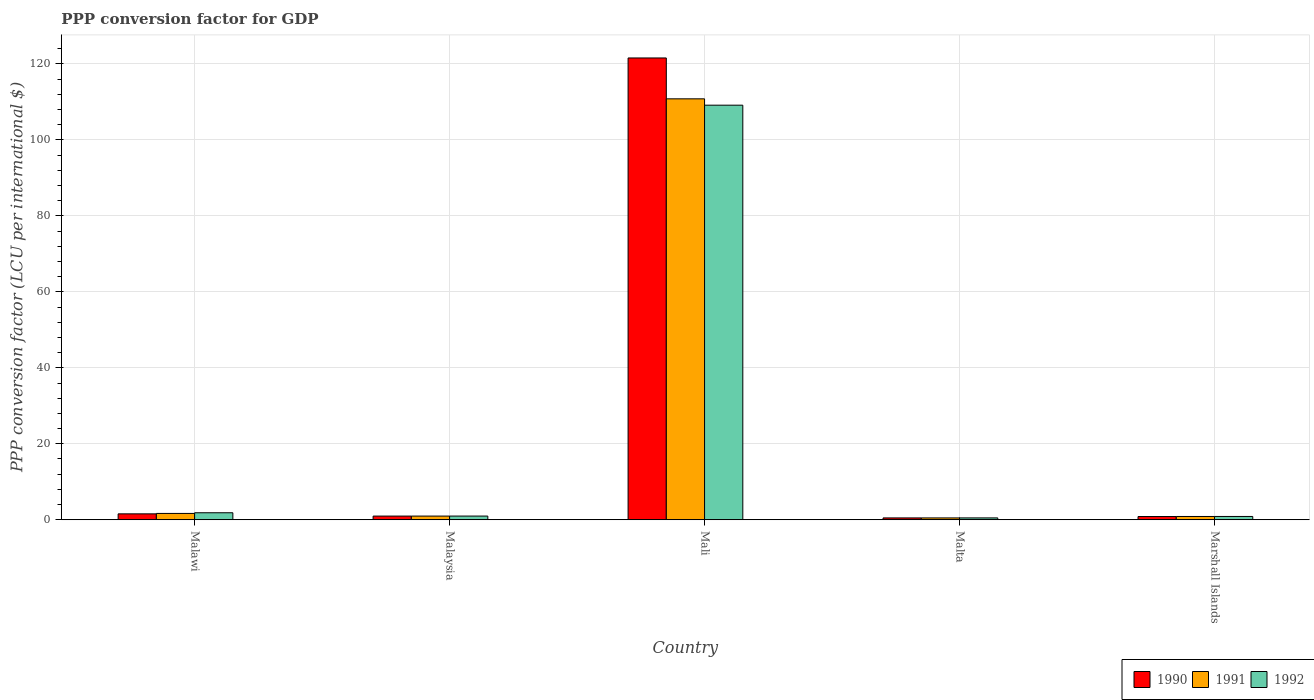How many different coloured bars are there?
Your answer should be compact. 3. How many groups of bars are there?
Your answer should be compact. 5. Are the number of bars on each tick of the X-axis equal?
Provide a succinct answer. Yes. How many bars are there on the 1st tick from the left?
Make the answer very short. 3. What is the label of the 3rd group of bars from the left?
Keep it short and to the point. Mali. In how many cases, is the number of bars for a given country not equal to the number of legend labels?
Make the answer very short. 0. What is the PPP conversion factor for GDP in 1990 in Malta?
Your answer should be very brief. 0.49. Across all countries, what is the maximum PPP conversion factor for GDP in 1991?
Provide a succinct answer. 110.8. Across all countries, what is the minimum PPP conversion factor for GDP in 1992?
Offer a very short reply. 0.49. In which country was the PPP conversion factor for GDP in 1990 maximum?
Your answer should be very brief. Mali. In which country was the PPP conversion factor for GDP in 1991 minimum?
Offer a very short reply. Malta. What is the total PPP conversion factor for GDP in 1992 in the graph?
Your answer should be very brief. 113.32. What is the difference between the PPP conversion factor for GDP in 1990 in Malawi and that in Malta?
Provide a succinct answer. 1.07. What is the difference between the PPP conversion factor for GDP in 1990 in Malta and the PPP conversion factor for GDP in 1991 in Marshall Islands?
Ensure brevity in your answer.  -0.38. What is the average PPP conversion factor for GDP in 1990 per country?
Your answer should be compact. 25.08. What is the difference between the PPP conversion factor for GDP of/in 1992 and PPP conversion factor for GDP of/in 1991 in Malawi?
Offer a very short reply. 0.18. What is the ratio of the PPP conversion factor for GDP in 1991 in Malawi to that in Malta?
Your response must be concise. 3.42. Is the PPP conversion factor for GDP in 1990 in Malaysia less than that in Mali?
Offer a terse response. Yes. What is the difference between the highest and the second highest PPP conversion factor for GDP in 1992?
Provide a succinct answer. -0.87. What is the difference between the highest and the lowest PPP conversion factor for GDP in 1992?
Give a very brief answer. 108.64. In how many countries, is the PPP conversion factor for GDP in 1992 greater than the average PPP conversion factor for GDP in 1992 taken over all countries?
Give a very brief answer. 1. Is the sum of the PPP conversion factor for GDP in 1990 in Malaysia and Malta greater than the maximum PPP conversion factor for GDP in 1992 across all countries?
Offer a very short reply. No. Are the values on the major ticks of Y-axis written in scientific E-notation?
Your answer should be very brief. No. Does the graph contain any zero values?
Keep it short and to the point. No. Does the graph contain grids?
Your answer should be very brief. Yes. Where does the legend appear in the graph?
Ensure brevity in your answer.  Bottom right. How are the legend labels stacked?
Offer a very short reply. Horizontal. What is the title of the graph?
Make the answer very short. PPP conversion factor for GDP. What is the label or title of the X-axis?
Ensure brevity in your answer.  Country. What is the label or title of the Y-axis?
Provide a succinct answer. PPP conversion factor (LCU per international $). What is the PPP conversion factor (LCU per international $) of 1990 in Malawi?
Give a very brief answer. 1.56. What is the PPP conversion factor (LCU per international $) in 1991 in Malawi?
Ensure brevity in your answer.  1.67. What is the PPP conversion factor (LCU per international $) of 1992 in Malawi?
Keep it short and to the point. 1.85. What is the PPP conversion factor (LCU per international $) in 1990 in Malaysia?
Offer a terse response. 0.97. What is the PPP conversion factor (LCU per international $) of 1991 in Malaysia?
Give a very brief answer. 0.97. What is the PPP conversion factor (LCU per international $) of 1992 in Malaysia?
Your answer should be compact. 0.97. What is the PPP conversion factor (LCU per international $) in 1990 in Mali?
Offer a terse response. 121.56. What is the PPP conversion factor (LCU per international $) of 1991 in Mali?
Give a very brief answer. 110.8. What is the PPP conversion factor (LCU per international $) of 1992 in Mali?
Make the answer very short. 109.13. What is the PPP conversion factor (LCU per international $) in 1990 in Malta?
Your answer should be compact. 0.49. What is the PPP conversion factor (LCU per international $) in 1991 in Malta?
Offer a terse response. 0.49. What is the PPP conversion factor (LCU per international $) in 1992 in Malta?
Your answer should be very brief. 0.49. What is the PPP conversion factor (LCU per international $) in 1990 in Marshall Islands?
Your response must be concise. 0.85. What is the PPP conversion factor (LCU per international $) in 1991 in Marshall Islands?
Give a very brief answer. 0.86. What is the PPP conversion factor (LCU per international $) of 1992 in Marshall Islands?
Give a very brief answer. 0.87. Across all countries, what is the maximum PPP conversion factor (LCU per international $) in 1990?
Offer a very short reply. 121.56. Across all countries, what is the maximum PPP conversion factor (LCU per international $) of 1991?
Provide a succinct answer. 110.8. Across all countries, what is the maximum PPP conversion factor (LCU per international $) in 1992?
Your response must be concise. 109.13. Across all countries, what is the minimum PPP conversion factor (LCU per international $) of 1990?
Your response must be concise. 0.49. Across all countries, what is the minimum PPP conversion factor (LCU per international $) in 1991?
Ensure brevity in your answer.  0.49. Across all countries, what is the minimum PPP conversion factor (LCU per international $) of 1992?
Give a very brief answer. 0.49. What is the total PPP conversion factor (LCU per international $) in 1990 in the graph?
Keep it short and to the point. 125.42. What is the total PPP conversion factor (LCU per international $) of 1991 in the graph?
Keep it short and to the point. 114.79. What is the total PPP conversion factor (LCU per international $) in 1992 in the graph?
Keep it short and to the point. 113.31. What is the difference between the PPP conversion factor (LCU per international $) in 1990 in Malawi and that in Malaysia?
Your answer should be compact. 0.59. What is the difference between the PPP conversion factor (LCU per international $) in 1991 in Malawi and that in Malaysia?
Keep it short and to the point. 0.7. What is the difference between the PPP conversion factor (LCU per international $) of 1992 in Malawi and that in Malaysia?
Offer a very short reply. 0.87. What is the difference between the PPP conversion factor (LCU per international $) in 1990 in Malawi and that in Mali?
Make the answer very short. -120.01. What is the difference between the PPP conversion factor (LCU per international $) in 1991 in Malawi and that in Mali?
Offer a very short reply. -109.14. What is the difference between the PPP conversion factor (LCU per international $) in 1992 in Malawi and that in Mali?
Ensure brevity in your answer.  -107.29. What is the difference between the PPP conversion factor (LCU per international $) of 1990 in Malawi and that in Malta?
Your answer should be very brief. 1.07. What is the difference between the PPP conversion factor (LCU per international $) in 1991 in Malawi and that in Malta?
Give a very brief answer. 1.18. What is the difference between the PPP conversion factor (LCU per international $) of 1992 in Malawi and that in Malta?
Provide a succinct answer. 1.35. What is the difference between the PPP conversion factor (LCU per international $) of 1990 in Malawi and that in Marshall Islands?
Offer a terse response. 0.71. What is the difference between the PPP conversion factor (LCU per international $) of 1991 in Malawi and that in Marshall Islands?
Give a very brief answer. 0.8. What is the difference between the PPP conversion factor (LCU per international $) of 1992 in Malawi and that in Marshall Islands?
Offer a terse response. 0.98. What is the difference between the PPP conversion factor (LCU per international $) of 1990 in Malaysia and that in Mali?
Keep it short and to the point. -120.59. What is the difference between the PPP conversion factor (LCU per international $) in 1991 in Malaysia and that in Mali?
Keep it short and to the point. -109.83. What is the difference between the PPP conversion factor (LCU per international $) in 1992 in Malaysia and that in Mali?
Give a very brief answer. -108.16. What is the difference between the PPP conversion factor (LCU per international $) in 1990 in Malaysia and that in Malta?
Make the answer very short. 0.48. What is the difference between the PPP conversion factor (LCU per international $) of 1991 in Malaysia and that in Malta?
Offer a very short reply. 0.48. What is the difference between the PPP conversion factor (LCU per international $) in 1992 in Malaysia and that in Malta?
Provide a succinct answer. 0.48. What is the difference between the PPP conversion factor (LCU per international $) of 1990 in Malaysia and that in Marshall Islands?
Provide a short and direct response. 0.12. What is the difference between the PPP conversion factor (LCU per international $) of 1991 in Malaysia and that in Marshall Islands?
Your response must be concise. 0.11. What is the difference between the PPP conversion factor (LCU per international $) of 1992 in Malaysia and that in Marshall Islands?
Your answer should be very brief. 0.1. What is the difference between the PPP conversion factor (LCU per international $) of 1990 in Mali and that in Malta?
Offer a terse response. 121.08. What is the difference between the PPP conversion factor (LCU per international $) in 1991 in Mali and that in Malta?
Make the answer very short. 110.32. What is the difference between the PPP conversion factor (LCU per international $) of 1992 in Mali and that in Malta?
Make the answer very short. 108.64. What is the difference between the PPP conversion factor (LCU per international $) of 1990 in Mali and that in Marshall Islands?
Provide a succinct answer. 120.71. What is the difference between the PPP conversion factor (LCU per international $) in 1991 in Mali and that in Marshall Islands?
Provide a succinct answer. 109.94. What is the difference between the PPP conversion factor (LCU per international $) of 1992 in Mali and that in Marshall Islands?
Offer a terse response. 108.26. What is the difference between the PPP conversion factor (LCU per international $) in 1990 in Malta and that in Marshall Islands?
Provide a succinct answer. -0.36. What is the difference between the PPP conversion factor (LCU per international $) in 1991 in Malta and that in Marshall Islands?
Your answer should be very brief. -0.38. What is the difference between the PPP conversion factor (LCU per international $) of 1992 in Malta and that in Marshall Islands?
Ensure brevity in your answer.  -0.38. What is the difference between the PPP conversion factor (LCU per international $) in 1990 in Malawi and the PPP conversion factor (LCU per international $) in 1991 in Malaysia?
Make the answer very short. 0.59. What is the difference between the PPP conversion factor (LCU per international $) in 1990 in Malawi and the PPP conversion factor (LCU per international $) in 1992 in Malaysia?
Your answer should be compact. 0.58. What is the difference between the PPP conversion factor (LCU per international $) of 1991 in Malawi and the PPP conversion factor (LCU per international $) of 1992 in Malaysia?
Keep it short and to the point. 0.69. What is the difference between the PPP conversion factor (LCU per international $) of 1990 in Malawi and the PPP conversion factor (LCU per international $) of 1991 in Mali?
Your answer should be very brief. -109.25. What is the difference between the PPP conversion factor (LCU per international $) of 1990 in Malawi and the PPP conversion factor (LCU per international $) of 1992 in Mali?
Give a very brief answer. -107.58. What is the difference between the PPP conversion factor (LCU per international $) of 1991 in Malawi and the PPP conversion factor (LCU per international $) of 1992 in Mali?
Keep it short and to the point. -107.47. What is the difference between the PPP conversion factor (LCU per international $) in 1990 in Malawi and the PPP conversion factor (LCU per international $) in 1991 in Malta?
Your answer should be very brief. 1.07. What is the difference between the PPP conversion factor (LCU per international $) of 1990 in Malawi and the PPP conversion factor (LCU per international $) of 1992 in Malta?
Keep it short and to the point. 1.06. What is the difference between the PPP conversion factor (LCU per international $) in 1991 in Malawi and the PPP conversion factor (LCU per international $) in 1992 in Malta?
Provide a short and direct response. 1.17. What is the difference between the PPP conversion factor (LCU per international $) in 1990 in Malawi and the PPP conversion factor (LCU per international $) in 1991 in Marshall Islands?
Ensure brevity in your answer.  0.69. What is the difference between the PPP conversion factor (LCU per international $) of 1990 in Malawi and the PPP conversion factor (LCU per international $) of 1992 in Marshall Islands?
Ensure brevity in your answer.  0.69. What is the difference between the PPP conversion factor (LCU per international $) in 1991 in Malawi and the PPP conversion factor (LCU per international $) in 1992 in Marshall Islands?
Make the answer very short. 0.8. What is the difference between the PPP conversion factor (LCU per international $) in 1990 in Malaysia and the PPP conversion factor (LCU per international $) in 1991 in Mali?
Your answer should be very brief. -109.84. What is the difference between the PPP conversion factor (LCU per international $) in 1990 in Malaysia and the PPP conversion factor (LCU per international $) in 1992 in Mali?
Your answer should be very brief. -108.17. What is the difference between the PPP conversion factor (LCU per international $) in 1991 in Malaysia and the PPP conversion factor (LCU per international $) in 1992 in Mali?
Your response must be concise. -108.16. What is the difference between the PPP conversion factor (LCU per international $) of 1990 in Malaysia and the PPP conversion factor (LCU per international $) of 1991 in Malta?
Ensure brevity in your answer.  0.48. What is the difference between the PPP conversion factor (LCU per international $) of 1990 in Malaysia and the PPP conversion factor (LCU per international $) of 1992 in Malta?
Give a very brief answer. 0.48. What is the difference between the PPP conversion factor (LCU per international $) in 1991 in Malaysia and the PPP conversion factor (LCU per international $) in 1992 in Malta?
Your answer should be very brief. 0.48. What is the difference between the PPP conversion factor (LCU per international $) of 1990 in Malaysia and the PPP conversion factor (LCU per international $) of 1991 in Marshall Islands?
Make the answer very short. 0.1. What is the difference between the PPP conversion factor (LCU per international $) of 1990 in Malaysia and the PPP conversion factor (LCU per international $) of 1992 in Marshall Islands?
Provide a short and direct response. 0.1. What is the difference between the PPP conversion factor (LCU per international $) in 1991 in Malaysia and the PPP conversion factor (LCU per international $) in 1992 in Marshall Islands?
Your response must be concise. 0.1. What is the difference between the PPP conversion factor (LCU per international $) of 1990 in Mali and the PPP conversion factor (LCU per international $) of 1991 in Malta?
Make the answer very short. 121.08. What is the difference between the PPP conversion factor (LCU per international $) of 1990 in Mali and the PPP conversion factor (LCU per international $) of 1992 in Malta?
Offer a very short reply. 121.07. What is the difference between the PPP conversion factor (LCU per international $) of 1991 in Mali and the PPP conversion factor (LCU per international $) of 1992 in Malta?
Your answer should be very brief. 110.31. What is the difference between the PPP conversion factor (LCU per international $) in 1990 in Mali and the PPP conversion factor (LCU per international $) in 1991 in Marshall Islands?
Give a very brief answer. 120.7. What is the difference between the PPP conversion factor (LCU per international $) of 1990 in Mali and the PPP conversion factor (LCU per international $) of 1992 in Marshall Islands?
Ensure brevity in your answer.  120.69. What is the difference between the PPP conversion factor (LCU per international $) of 1991 in Mali and the PPP conversion factor (LCU per international $) of 1992 in Marshall Islands?
Ensure brevity in your answer.  109.93. What is the difference between the PPP conversion factor (LCU per international $) in 1990 in Malta and the PPP conversion factor (LCU per international $) in 1991 in Marshall Islands?
Ensure brevity in your answer.  -0.38. What is the difference between the PPP conversion factor (LCU per international $) of 1990 in Malta and the PPP conversion factor (LCU per international $) of 1992 in Marshall Islands?
Make the answer very short. -0.38. What is the difference between the PPP conversion factor (LCU per international $) of 1991 in Malta and the PPP conversion factor (LCU per international $) of 1992 in Marshall Islands?
Your answer should be very brief. -0.38. What is the average PPP conversion factor (LCU per international $) of 1990 per country?
Offer a very short reply. 25.08. What is the average PPP conversion factor (LCU per international $) of 1991 per country?
Your answer should be compact. 22.96. What is the average PPP conversion factor (LCU per international $) of 1992 per country?
Your answer should be very brief. 22.66. What is the difference between the PPP conversion factor (LCU per international $) of 1990 and PPP conversion factor (LCU per international $) of 1991 in Malawi?
Offer a terse response. -0.11. What is the difference between the PPP conversion factor (LCU per international $) in 1990 and PPP conversion factor (LCU per international $) in 1992 in Malawi?
Offer a terse response. -0.29. What is the difference between the PPP conversion factor (LCU per international $) of 1991 and PPP conversion factor (LCU per international $) of 1992 in Malawi?
Keep it short and to the point. -0.18. What is the difference between the PPP conversion factor (LCU per international $) of 1990 and PPP conversion factor (LCU per international $) of 1991 in Malaysia?
Give a very brief answer. -0. What is the difference between the PPP conversion factor (LCU per international $) of 1990 and PPP conversion factor (LCU per international $) of 1992 in Malaysia?
Make the answer very short. -0. What is the difference between the PPP conversion factor (LCU per international $) in 1991 and PPP conversion factor (LCU per international $) in 1992 in Malaysia?
Ensure brevity in your answer.  -0. What is the difference between the PPP conversion factor (LCU per international $) of 1990 and PPP conversion factor (LCU per international $) of 1991 in Mali?
Make the answer very short. 10.76. What is the difference between the PPP conversion factor (LCU per international $) of 1990 and PPP conversion factor (LCU per international $) of 1992 in Mali?
Offer a very short reply. 12.43. What is the difference between the PPP conversion factor (LCU per international $) of 1991 and PPP conversion factor (LCU per international $) of 1992 in Mali?
Offer a terse response. 1.67. What is the difference between the PPP conversion factor (LCU per international $) of 1990 and PPP conversion factor (LCU per international $) of 1991 in Malta?
Your answer should be compact. -0. What is the difference between the PPP conversion factor (LCU per international $) in 1990 and PPP conversion factor (LCU per international $) in 1992 in Malta?
Offer a very short reply. -0.01. What is the difference between the PPP conversion factor (LCU per international $) in 1991 and PPP conversion factor (LCU per international $) in 1992 in Malta?
Provide a succinct answer. -0.01. What is the difference between the PPP conversion factor (LCU per international $) of 1990 and PPP conversion factor (LCU per international $) of 1991 in Marshall Islands?
Ensure brevity in your answer.  -0.01. What is the difference between the PPP conversion factor (LCU per international $) of 1990 and PPP conversion factor (LCU per international $) of 1992 in Marshall Islands?
Make the answer very short. -0.02. What is the difference between the PPP conversion factor (LCU per international $) in 1991 and PPP conversion factor (LCU per international $) in 1992 in Marshall Islands?
Offer a very short reply. -0.01. What is the ratio of the PPP conversion factor (LCU per international $) of 1990 in Malawi to that in Malaysia?
Your response must be concise. 1.61. What is the ratio of the PPP conversion factor (LCU per international $) of 1991 in Malawi to that in Malaysia?
Make the answer very short. 1.72. What is the ratio of the PPP conversion factor (LCU per international $) in 1992 in Malawi to that in Malaysia?
Your answer should be very brief. 1.9. What is the ratio of the PPP conversion factor (LCU per international $) of 1990 in Malawi to that in Mali?
Provide a short and direct response. 0.01. What is the ratio of the PPP conversion factor (LCU per international $) in 1991 in Malawi to that in Mali?
Ensure brevity in your answer.  0.01. What is the ratio of the PPP conversion factor (LCU per international $) of 1992 in Malawi to that in Mali?
Your answer should be very brief. 0.02. What is the ratio of the PPP conversion factor (LCU per international $) in 1990 in Malawi to that in Malta?
Offer a terse response. 3.2. What is the ratio of the PPP conversion factor (LCU per international $) in 1991 in Malawi to that in Malta?
Offer a terse response. 3.42. What is the ratio of the PPP conversion factor (LCU per international $) of 1992 in Malawi to that in Malta?
Offer a terse response. 3.74. What is the ratio of the PPP conversion factor (LCU per international $) of 1990 in Malawi to that in Marshall Islands?
Give a very brief answer. 1.83. What is the ratio of the PPP conversion factor (LCU per international $) in 1991 in Malawi to that in Marshall Islands?
Ensure brevity in your answer.  1.93. What is the ratio of the PPP conversion factor (LCU per international $) of 1992 in Malawi to that in Marshall Islands?
Make the answer very short. 2.12. What is the ratio of the PPP conversion factor (LCU per international $) of 1990 in Malaysia to that in Mali?
Offer a terse response. 0.01. What is the ratio of the PPP conversion factor (LCU per international $) of 1991 in Malaysia to that in Mali?
Your answer should be compact. 0.01. What is the ratio of the PPP conversion factor (LCU per international $) of 1992 in Malaysia to that in Mali?
Provide a short and direct response. 0.01. What is the ratio of the PPP conversion factor (LCU per international $) of 1990 in Malaysia to that in Malta?
Your response must be concise. 1.99. What is the ratio of the PPP conversion factor (LCU per international $) of 1991 in Malaysia to that in Malta?
Your answer should be very brief. 1.99. What is the ratio of the PPP conversion factor (LCU per international $) of 1992 in Malaysia to that in Malta?
Give a very brief answer. 1.97. What is the ratio of the PPP conversion factor (LCU per international $) in 1990 in Malaysia to that in Marshall Islands?
Offer a very short reply. 1.14. What is the ratio of the PPP conversion factor (LCU per international $) of 1991 in Malaysia to that in Marshall Islands?
Provide a short and direct response. 1.12. What is the ratio of the PPP conversion factor (LCU per international $) of 1992 in Malaysia to that in Marshall Islands?
Make the answer very short. 1.12. What is the ratio of the PPP conversion factor (LCU per international $) in 1990 in Mali to that in Malta?
Provide a short and direct response. 249.76. What is the ratio of the PPP conversion factor (LCU per international $) of 1991 in Mali to that in Malta?
Keep it short and to the point. 227.61. What is the ratio of the PPP conversion factor (LCU per international $) of 1992 in Mali to that in Malta?
Offer a very short reply. 221.42. What is the ratio of the PPP conversion factor (LCU per international $) of 1990 in Mali to that in Marshall Islands?
Your response must be concise. 143.05. What is the ratio of the PPP conversion factor (LCU per international $) in 1991 in Mali to that in Marshall Islands?
Your answer should be very brief. 128.26. What is the ratio of the PPP conversion factor (LCU per international $) of 1992 in Mali to that in Marshall Islands?
Your answer should be very brief. 125.42. What is the ratio of the PPP conversion factor (LCU per international $) in 1990 in Malta to that in Marshall Islands?
Your response must be concise. 0.57. What is the ratio of the PPP conversion factor (LCU per international $) in 1991 in Malta to that in Marshall Islands?
Keep it short and to the point. 0.56. What is the ratio of the PPP conversion factor (LCU per international $) in 1992 in Malta to that in Marshall Islands?
Ensure brevity in your answer.  0.57. What is the difference between the highest and the second highest PPP conversion factor (LCU per international $) of 1990?
Provide a succinct answer. 120.01. What is the difference between the highest and the second highest PPP conversion factor (LCU per international $) of 1991?
Your answer should be compact. 109.14. What is the difference between the highest and the second highest PPP conversion factor (LCU per international $) in 1992?
Give a very brief answer. 107.29. What is the difference between the highest and the lowest PPP conversion factor (LCU per international $) of 1990?
Provide a short and direct response. 121.08. What is the difference between the highest and the lowest PPP conversion factor (LCU per international $) in 1991?
Offer a very short reply. 110.32. What is the difference between the highest and the lowest PPP conversion factor (LCU per international $) in 1992?
Your answer should be very brief. 108.64. 